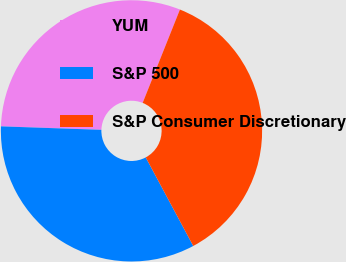Convert chart. <chart><loc_0><loc_0><loc_500><loc_500><pie_chart><fcel>YUM<fcel>S&P 500<fcel>S&P Consumer Discretionary<nl><fcel>30.5%<fcel>33.39%<fcel>36.12%<nl></chart> 